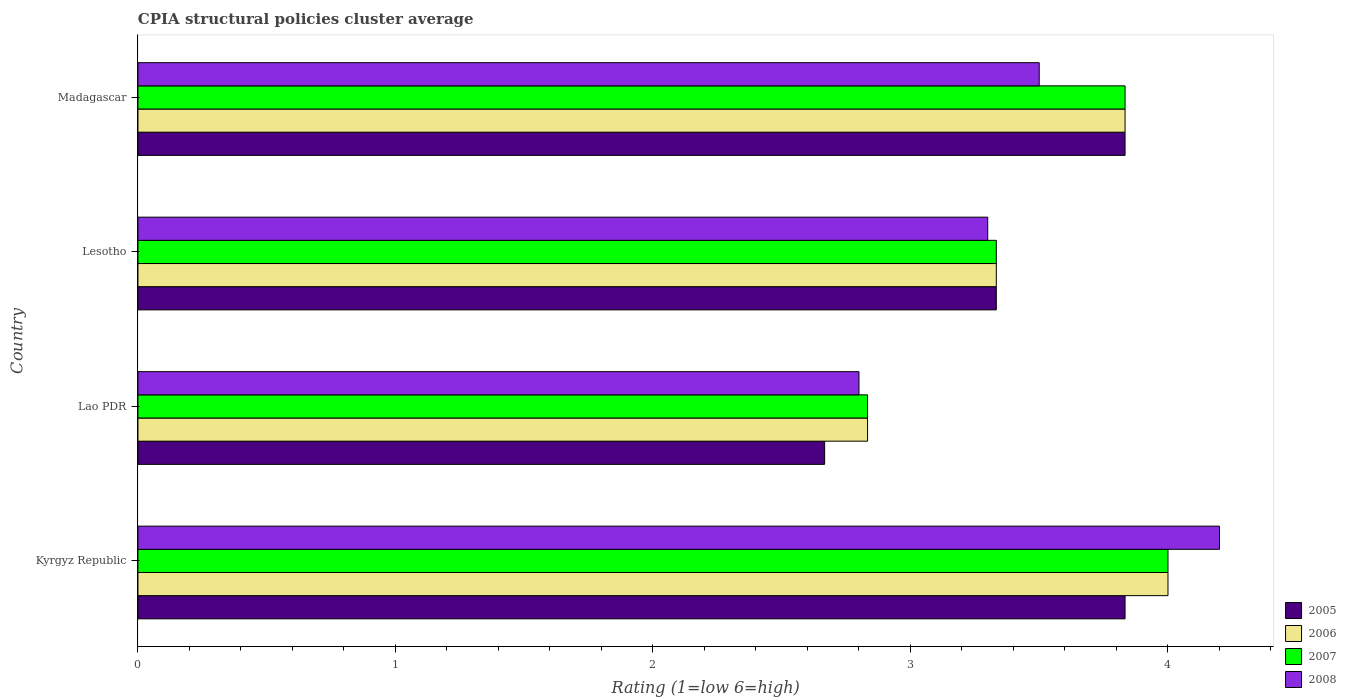How many groups of bars are there?
Your answer should be very brief. 4. How many bars are there on the 2nd tick from the bottom?
Ensure brevity in your answer.  4. What is the label of the 3rd group of bars from the top?
Offer a terse response. Lao PDR. Across all countries, what is the maximum CPIA rating in 2005?
Your answer should be compact. 3.83. Across all countries, what is the minimum CPIA rating in 2007?
Provide a short and direct response. 2.83. In which country was the CPIA rating in 2005 maximum?
Offer a very short reply. Kyrgyz Republic. In which country was the CPIA rating in 2006 minimum?
Make the answer very short. Lao PDR. What is the total CPIA rating in 2008 in the graph?
Make the answer very short. 13.8. What is the difference between the CPIA rating in 2007 in Kyrgyz Republic and that in Lao PDR?
Give a very brief answer. 1.17. What is the difference between the CPIA rating in 2005 in Lao PDR and the CPIA rating in 2006 in Lesotho?
Offer a terse response. -0.67. What is the average CPIA rating in 2006 per country?
Ensure brevity in your answer.  3.5. In how many countries, is the CPIA rating in 2007 greater than 2.4 ?
Make the answer very short. 4. What is the ratio of the CPIA rating in 2006 in Lao PDR to that in Madagascar?
Ensure brevity in your answer.  0.74. Is the difference between the CPIA rating in 2005 in Kyrgyz Republic and Madagascar greater than the difference between the CPIA rating in 2006 in Kyrgyz Republic and Madagascar?
Your response must be concise. No. What is the difference between the highest and the lowest CPIA rating in 2008?
Provide a short and direct response. 1.4. In how many countries, is the CPIA rating in 2005 greater than the average CPIA rating in 2005 taken over all countries?
Ensure brevity in your answer.  2. Is it the case that in every country, the sum of the CPIA rating in 2007 and CPIA rating in 2006 is greater than the sum of CPIA rating in 2005 and CPIA rating in 2008?
Ensure brevity in your answer.  No. What does the 2nd bar from the top in Lesotho represents?
Provide a succinct answer. 2007. What does the 1st bar from the bottom in Lesotho represents?
Ensure brevity in your answer.  2005. Is it the case that in every country, the sum of the CPIA rating in 2006 and CPIA rating in 2008 is greater than the CPIA rating in 2005?
Provide a succinct answer. Yes. How many bars are there?
Provide a succinct answer. 16. How many countries are there in the graph?
Keep it short and to the point. 4. Are the values on the major ticks of X-axis written in scientific E-notation?
Make the answer very short. No. Does the graph contain any zero values?
Ensure brevity in your answer.  No. What is the title of the graph?
Provide a short and direct response. CPIA structural policies cluster average. What is the Rating (1=low 6=high) in 2005 in Kyrgyz Republic?
Keep it short and to the point. 3.83. What is the Rating (1=low 6=high) in 2008 in Kyrgyz Republic?
Provide a short and direct response. 4.2. What is the Rating (1=low 6=high) of 2005 in Lao PDR?
Keep it short and to the point. 2.67. What is the Rating (1=low 6=high) of 2006 in Lao PDR?
Ensure brevity in your answer.  2.83. What is the Rating (1=low 6=high) of 2007 in Lao PDR?
Your answer should be compact. 2.83. What is the Rating (1=low 6=high) of 2005 in Lesotho?
Keep it short and to the point. 3.33. What is the Rating (1=low 6=high) in 2006 in Lesotho?
Your answer should be compact. 3.33. What is the Rating (1=low 6=high) of 2007 in Lesotho?
Offer a very short reply. 3.33. What is the Rating (1=low 6=high) in 2008 in Lesotho?
Your answer should be compact. 3.3. What is the Rating (1=low 6=high) of 2005 in Madagascar?
Offer a very short reply. 3.83. What is the Rating (1=low 6=high) in 2006 in Madagascar?
Your answer should be compact. 3.83. What is the Rating (1=low 6=high) of 2007 in Madagascar?
Your answer should be very brief. 3.83. Across all countries, what is the maximum Rating (1=low 6=high) of 2005?
Provide a succinct answer. 3.83. Across all countries, what is the maximum Rating (1=low 6=high) in 2007?
Ensure brevity in your answer.  4. Across all countries, what is the minimum Rating (1=low 6=high) of 2005?
Your answer should be very brief. 2.67. Across all countries, what is the minimum Rating (1=low 6=high) in 2006?
Offer a terse response. 2.83. Across all countries, what is the minimum Rating (1=low 6=high) of 2007?
Provide a short and direct response. 2.83. Across all countries, what is the minimum Rating (1=low 6=high) in 2008?
Ensure brevity in your answer.  2.8. What is the total Rating (1=low 6=high) in 2005 in the graph?
Make the answer very short. 13.67. What is the total Rating (1=low 6=high) of 2008 in the graph?
Make the answer very short. 13.8. What is the difference between the Rating (1=low 6=high) of 2006 in Kyrgyz Republic and that in Lao PDR?
Give a very brief answer. 1.17. What is the difference between the Rating (1=low 6=high) in 2007 in Kyrgyz Republic and that in Lao PDR?
Offer a very short reply. 1.17. What is the difference between the Rating (1=low 6=high) in 2008 in Kyrgyz Republic and that in Lao PDR?
Keep it short and to the point. 1.4. What is the difference between the Rating (1=low 6=high) of 2005 in Kyrgyz Republic and that in Lesotho?
Make the answer very short. 0.5. What is the difference between the Rating (1=low 6=high) of 2007 in Kyrgyz Republic and that in Lesotho?
Make the answer very short. 0.67. What is the difference between the Rating (1=low 6=high) of 2005 in Kyrgyz Republic and that in Madagascar?
Your answer should be very brief. 0. What is the difference between the Rating (1=low 6=high) in 2006 in Kyrgyz Republic and that in Madagascar?
Make the answer very short. 0.17. What is the difference between the Rating (1=low 6=high) in 2007 in Kyrgyz Republic and that in Madagascar?
Make the answer very short. 0.17. What is the difference between the Rating (1=low 6=high) in 2005 in Lao PDR and that in Lesotho?
Ensure brevity in your answer.  -0.67. What is the difference between the Rating (1=low 6=high) in 2007 in Lao PDR and that in Lesotho?
Your response must be concise. -0.5. What is the difference between the Rating (1=low 6=high) in 2005 in Lao PDR and that in Madagascar?
Keep it short and to the point. -1.17. What is the difference between the Rating (1=low 6=high) of 2007 in Lao PDR and that in Madagascar?
Offer a terse response. -1. What is the difference between the Rating (1=low 6=high) of 2007 in Lesotho and that in Madagascar?
Give a very brief answer. -0.5. What is the difference between the Rating (1=low 6=high) of 2005 in Kyrgyz Republic and the Rating (1=low 6=high) of 2006 in Lao PDR?
Offer a terse response. 1. What is the difference between the Rating (1=low 6=high) of 2005 in Kyrgyz Republic and the Rating (1=low 6=high) of 2007 in Lao PDR?
Ensure brevity in your answer.  1. What is the difference between the Rating (1=low 6=high) of 2005 in Kyrgyz Republic and the Rating (1=low 6=high) of 2008 in Lao PDR?
Provide a short and direct response. 1.03. What is the difference between the Rating (1=low 6=high) of 2006 in Kyrgyz Republic and the Rating (1=low 6=high) of 2007 in Lao PDR?
Offer a terse response. 1.17. What is the difference between the Rating (1=low 6=high) of 2005 in Kyrgyz Republic and the Rating (1=low 6=high) of 2006 in Lesotho?
Provide a succinct answer. 0.5. What is the difference between the Rating (1=low 6=high) in 2005 in Kyrgyz Republic and the Rating (1=low 6=high) in 2007 in Lesotho?
Offer a terse response. 0.5. What is the difference between the Rating (1=low 6=high) in 2005 in Kyrgyz Republic and the Rating (1=low 6=high) in 2008 in Lesotho?
Make the answer very short. 0.53. What is the difference between the Rating (1=low 6=high) of 2006 in Kyrgyz Republic and the Rating (1=low 6=high) of 2007 in Lesotho?
Keep it short and to the point. 0.67. What is the difference between the Rating (1=low 6=high) of 2007 in Kyrgyz Republic and the Rating (1=low 6=high) of 2008 in Lesotho?
Ensure brevity in your answer.  0.7. What is the difference between the Rating (1=low 6=high) of 2005 in Kyrgyz Republic and the Rating (1=low 6=high) of 2006 in Madagascar?
Your answer should be very brief. 0. What is the difference between the Rating (1=low 6=high) in 2005 in Kyrgyz Republic and the Rating (1=low 6=high) in 2008 in Madagascar?
Ensure brevity in your answer.  0.33. What is the difference between the Rating (1=low 6=high) of 2006 in Kyrgyz Republic and the Rating (1=low 6=high) of 2007 in Madagascar?
Offer a terse response. 0.17. What is the difference between the Rating (1=low 6=high) in 2006 in Kyrgyz Republic and the Rating (1=low 6=high) in 2008 in Madagascar?
Offer a very short reply. 0.5. What is the difference between the Rating (1=low 6=high) in 2005 in Lao PDR and the Rating (1=low 6=high) in 2007 in Lesotho?
Your answer should be compact. -0.67. What is the difference between the Rating (1=low 6=high) in 2005 in Lao PDR and the Rating (1=low 6=high) in 2008 in Lesotho?
Your answer should be very brief. -0.63. What is the difference between the Rating (1=low 6=high) in 2006 in Lao PDR and the Rating (1=low 6=high) in 2007 in Lesotho?
Offer a very short reply. -0.5. What is the difference between the Rating (1=low 6=high) in 2006 in Lao PDR and the Rating (1=low 6=high) in 2008 in Lesotho?
Ensure brevity in your answer.  -0.47. What is the difference between the Rating (1=low 6=high) of 2007 in Lao PDR and the Rating (1=low 6=high) of 2008 in Lesotho?
Make the answer very short. -0.47. What is the difference between the Rating (1=low 6=high) of 2005 in Lao PDR and the Rating (1=low 6=high) of 2006 in Madagascar?
Offer a very short reply. -1.17. What is the difference between the Rating (1=low 6=high) in 2005 in Lao PDR and the Rating (1=low 6=high) in 2007 in Madagascar?
Your response must be concise. -1.17. What is the difference between the Rating (1=low 6=high) in 2005 in Lao PDR and the Rating (1=low 6=high) in 2008 in Madagascar?
Provide a succinct answer. -0.83. What is the difference between the Rating (1=low 6=high) of 2006 in Lao PDR and the Rating (1=low 6=high) of 2007 in Madagascar?
Offer a very short reply. -1. What is the difference between the Rating (1=low 6=high) of 2006 in Lao PDR and the Rating (1=low 6=high) of 2008 in Madagascar?
Offer a terse response. -0.67. What is the difference between the Rating (1=low 6=high) of 2007 in Lao PDR and the Rating (1=low 6=high) of 2008 in Madagascar?
Provide a short and direct response. -0.67. What is the difference between the Rating (1=low 6=high) of 2005 in Lesotho and the Rating (1=low 6=high) of 2006 in Madagascar?
Provide a succinct answer. -0.5. What is the difference between the Rating (1=low 6=high) of 2005 in Lesotho and the Rating (1=low 6=high) of 2007 in Madagascar?
Make the answer very short. -0.5. What is the difference between the Rating (1=low 6=high) of 2005 in Lesotho and the Rating (1=low 6=high) of 2008 in Madagascar?
Ensure brevity in your answer.  -0.17. What is the difference between the Rating (1=low 6=high) of 2006 in Lesotho and the Rating (1=low 6=high) of 2007 in Madagascar?
Provide a short and direct response. -0.5. What is the difference between the Rating (1=low 6=high) in 2006 in Lesotho and the Rating (1=low 6=high) in 2008 in Madagascar?
Keep it short and to the point. -0.17. What is the difference between the Rating (1=low 6=high) of 2007 in Lesotho and the Rating (1=low 6=high) of 2008 in Madagascar?
Your response must be concise. -0.17. What is the average Rating (1=low 6=high) of 2005 per country?
Offer a very short reply. 3.42. What is the average Rating (1=low 6=high) in 2008 per country?
Offer a terse response. 3.45. What is the difference between the Rating (1=low 6=high) in 2005 and Rating (1=low 6=high) in 2006 in Kyrgyz Republic?
Provide a succinct answer. -0.17. What is the difference between the Rating (1=low 6=high) of 2005 and Rating (1=low 6=high) of 2008 in Kyrgyz Republic?
Give a very brief answer. -0.37. What is the difference between the Rating (1=low 6=high) of 2006 and Rating (1=low 6=high) of 2007 in Kyrgyz Republic?
Your answer should be very brief. 0. What is the difference between the Rating (1=low 6=high) in 2005 and Rating (1=low 6=high) in 2007 in Lao PDR?
Keep it short and to the point. -0.17. What is the difference between the Rating (1=low 6=high) in 2005 and Rating (1=low 6=high) in 2008 in Lao PDR?
Make the answer very short. -0.13. What is the difference between the Rating (1=low 6=high) in 2006 and Rating (1=low 6=high) in 2007 in Lao PDR?
Offer a very short reply. 0. What is the difference between the Rating (1=low 6=high) of 2007 and Rating (1=low 6=high) of 2008 in Lao PDR?
Provide a short and direct response. 0.03. What is the difference between the Rating (1=low 6=high) of 2005 and Rating (1=low 6=high) of 2008 in Lesotho?
Offer a terse response. 0.03. What is the difference between the Rating (1=low 6=high) of 2006 and Rating (1=low 6=high) of 2008 in Lesotho?
Make the answer very short. 0.03. What is the difference between the Rating (1=low 6=high) in 2005 and Rating (1=low 6=high) in 2006 in Madagascar?
Offer a very short reply. 0. What is the difference between the Rating (1=low 6=high) of 2005 and Rating (1=low 6=high) of 2007 in Madagascar?
Make the answer very short. 0. What is the difference between the Rating (1=low 6=high) in 2006 and Rating (1=low 6=high) in 2008 in Madagascar?
Ensure brevity in your answer.  0.33. What is the difference between the Rating (1=low 6=high) in 2007 and Rating (1=low 6=high) in 2008 in Madagascar?
Provide a short and direct response. 0.33. What is the ratio of the Rating (1=low 6=high) of 2005 in Kyrgyz Republic to that in Lao PDR?
Your response must be concise. 1.44. What is the ratio of the Rating (1=low 6=high) in 2006 in Kyrgyz Republic to that in Lao PDR?
Your answer should be very brief. 1.41. What is the ratio of the Rating (1=low 6=high) in 2007 in Kyrgyz Republic to that in Lao PDR?
Offer a terse response. 1.41. What is the ratio of the Rating (1=low 6=high) in 2005 in Kyrgyz Republic to that in Lesotho?
Provide a succinct answer. 1.15. What is the ratio of the Rating (1=low 6=high) in 2006 in Kyrgyz Republic to that in Lesotho?
Keep it short and to the point. 1.2. What is the ratio of the Rating (1=low 6=high) of 2007 in Kyrgyz Republic to that in Lesotho?
Give a very brief answer. 1.2. What is the ratio of the Rating (1=low 6=high) of 2008 in Kyrgyz Republic to that in Lesotho?
Your response must be concise. 1.27. What is the ratio of the Rating (1=low 6=high) of 2006 in Kyrgyz Republic to that in Madagascar?
Your response must be concise. 1.04. What is the ratio of the Rating (1=low 6=high) in 2007 in Kyrgyz Republic to that in Madagascar?
Keep it short and to the point. 1.04. What is the ratio of the Rating (1=low 6=high) in 2008 in Lao PDR to that in Lesotho?
Ensure brevity in your answer.  0.85. What is the ratio of the Rating (1=low 6=high) of 2005 in Lao PDR to that in Madagascar?
Your answer should be compact. 0.7. What is the ratio of the Rating (1=low 6=high) in 2006 in Lao PDR to that in Madagascar?
Keep it short and to the point. 0.74. What is the ratio of the Rating (1=low 6=high) of 2007 in Lao PDR to that in Madagascar?
Your answer should be compact. 0.74. What is the ratio of the Rating (1=low 6=high) in 2008 in Lao PDR to that in Madagascar?
Offer a terse response. 0.8. What is the ratio of the Rating (1=low 6=high) of 2005 in Lesotho to that in Madagascar?
Provide a short and direct response. 0.87. What is the ratio of the Rating (1=low 6=high) of 2006 in Lesotho to that in Madagascar?
Offer a terse response. 0.87. What is the ratio of the Rating (1=low 6=high) in 2007 in Lesotho to that in Madagascar?
Keep it short and to the point. 0.87. What is the ratio of the Rating (1=low 6=high) of 2008 in Lesotho to that in Madagascar?
Offer a very short reply. 0.94. What is the difference between the highest and the second highest Rating (1=low 6=high) in 2005?
Your answer should be very brief. 0. What is the difference between the highest and the second highest Rating (1=low 6=high) of 2006?
Offer a very short reply. 0.17. What is the difference between the highest and the second highest Rating (1=low 6=high) in 2007?
Your answer should be compact. 0.17. What is the difference between the highest and the lowest Rating (1=low 6=high) of 2006?
Keep it short and to the point. 1.17. What is the difference between the highest and the lowest Rating (1=low 6=high) of 2008?
Offer a very short reply. 1.4. 